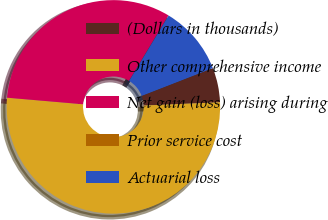Convert chart to OTSL. <chart><loc_0><loc_0><loc_500><loc_500><pie_chart><fcel>(Dollars in thousands)<fcel>Other comprehensive income<fcel>Net gain (loss) arising during<fcel>Prior service cost<fcel>Actuarial loss<nl><fcel>5.23%<fcel>52.05%<fcel>32.26%<fcel>0.02%<fcel>10.43%<nl></chart> 